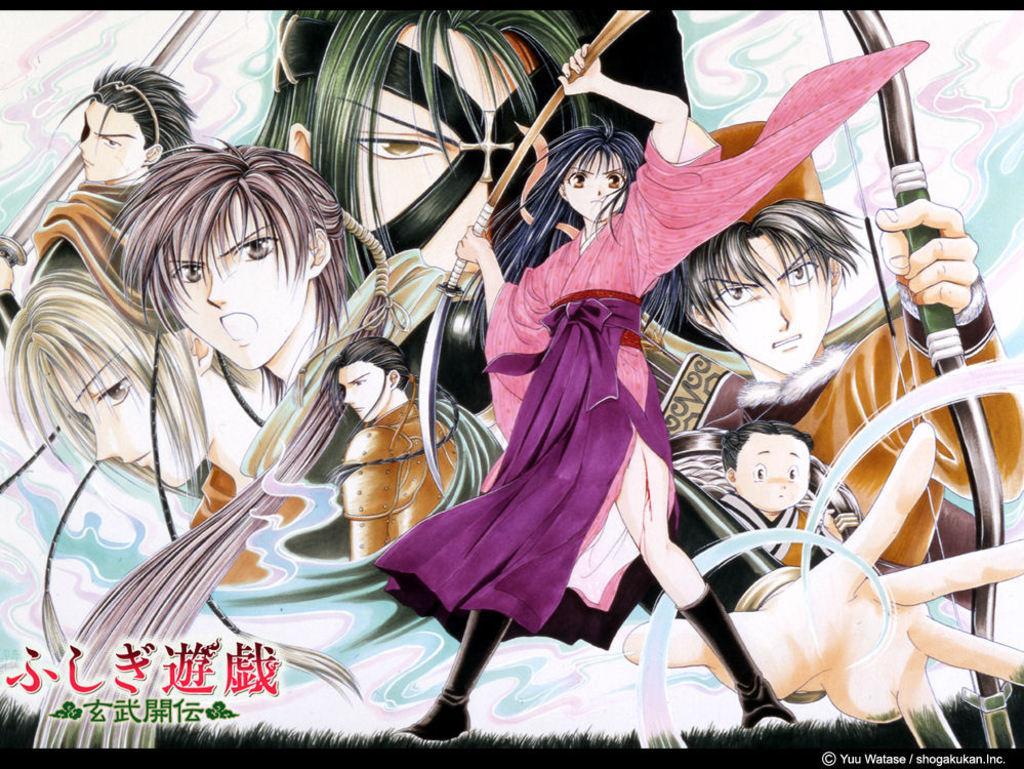Please provide a concise description of this image. In this image we can see an animated image of a group of persons. In the bottom left we can see some text in Chinese. In the bottom right we can see some text. 